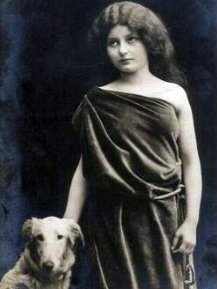Describe the objects in this image and their specific colors. I can see people in black, gray, darkgray, and lightgray tones and dog in black, gray, lightgray, and darkgray tones in this image. 